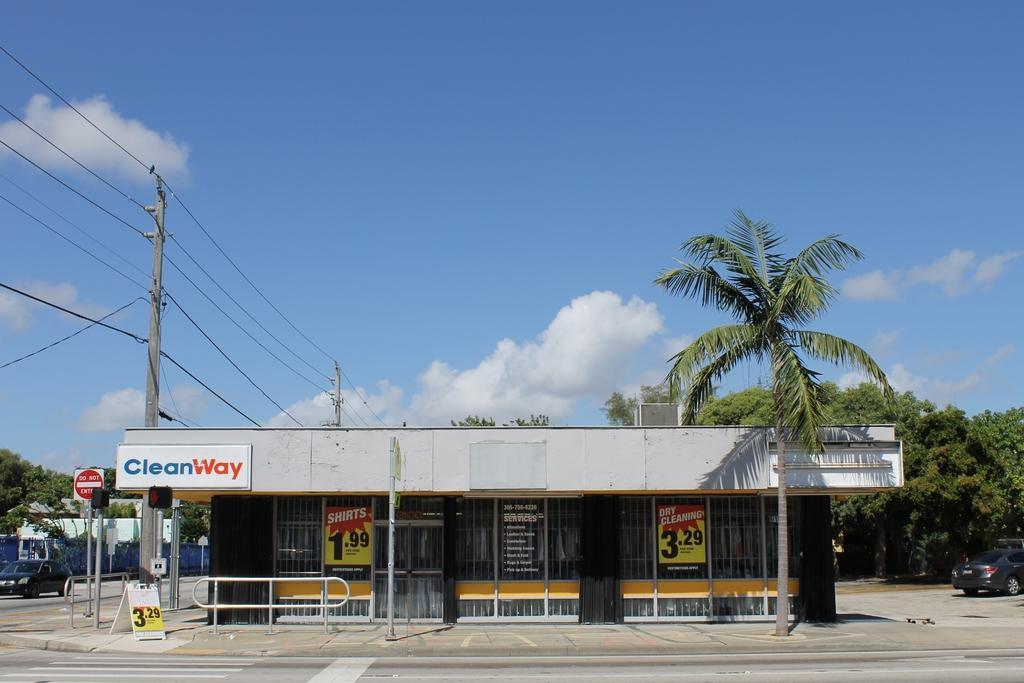Can you describe this image briefly? This image is clicked outside. There is a store in the middle. There are trees on the right side. There is a car on the left side. There is sky at the top. 